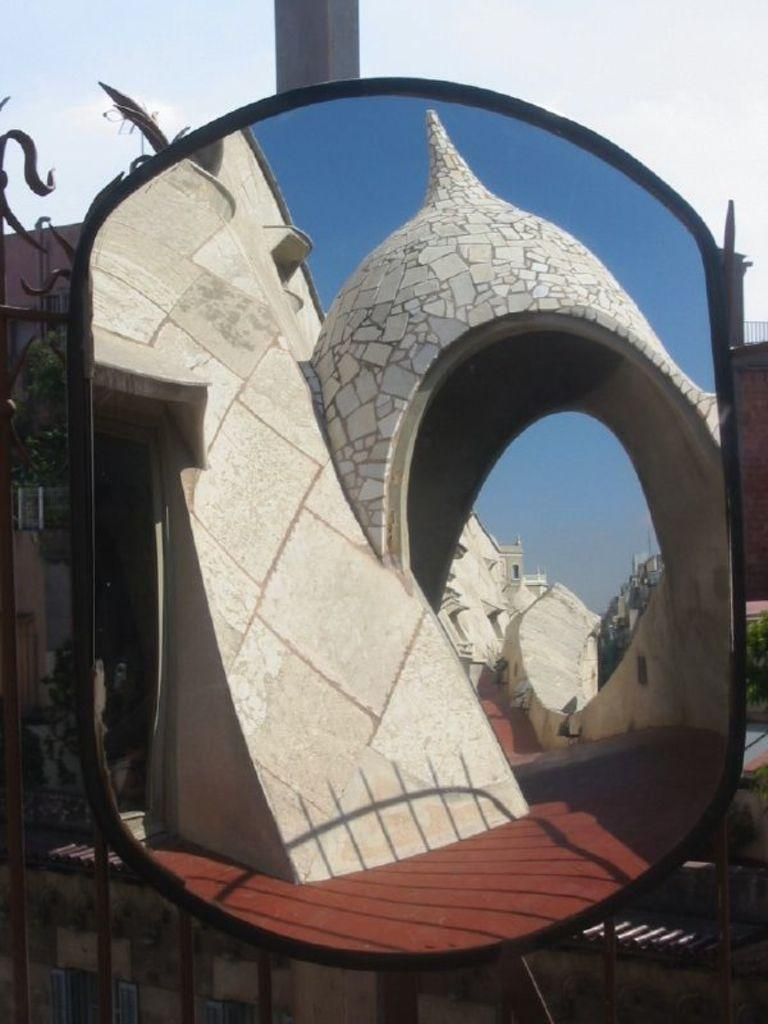What object is present in the image that can reflect images? There is a mirror in the image. What does the mirror reflect in the image? The mirror reflects an architectural building and the sky. What can be seen behind the mirror in the image? There are trees, a pole, and buildings behind the mirror. Is the mirror's reflection at a party in the image? There is no party present in the image; the mirror reflects an architectural building and the sky. How many daughters are visible in the mirror's reflection? There are no people, including daughters, visible in the mirror's reflection; it reflects an architectural building and the sky. 